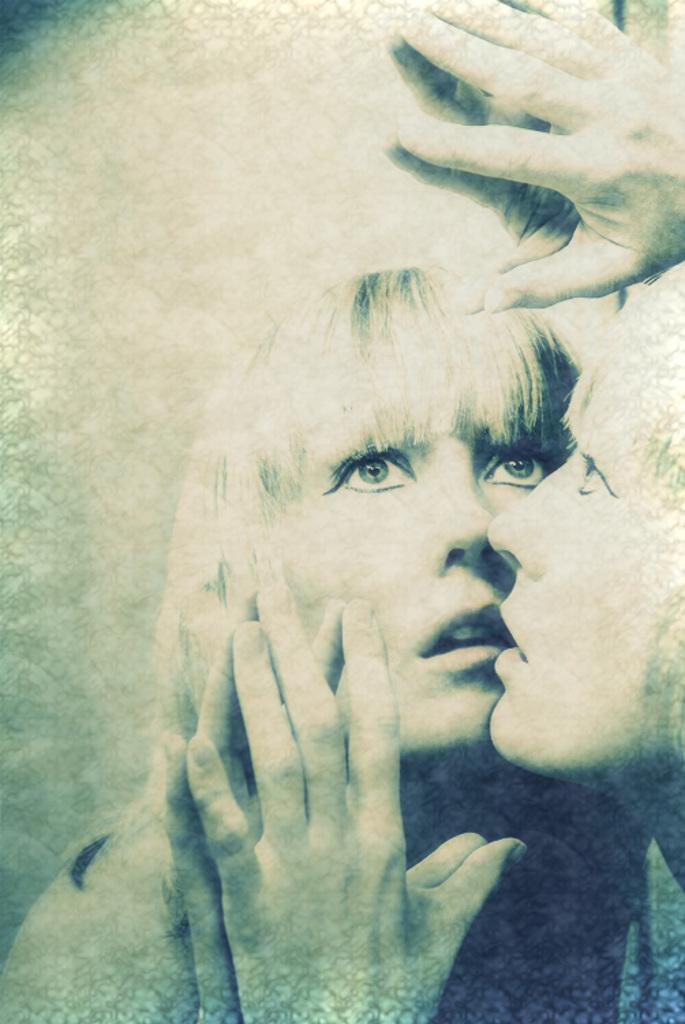Who is present in the image? There is a woman in the image. What is the woman doing in the image? The woman is standing in front of a mirror. Can you describe the reflection in the mirror? There is a reflection of the woman on the mirror. What is the color scheme of the image? The image is in black and white color. Is the woman stuck in quicksand in the image? No, there is no quicksand present in the image. What type of truck can be seen driving by in the image? There is no truck visible in the image. 